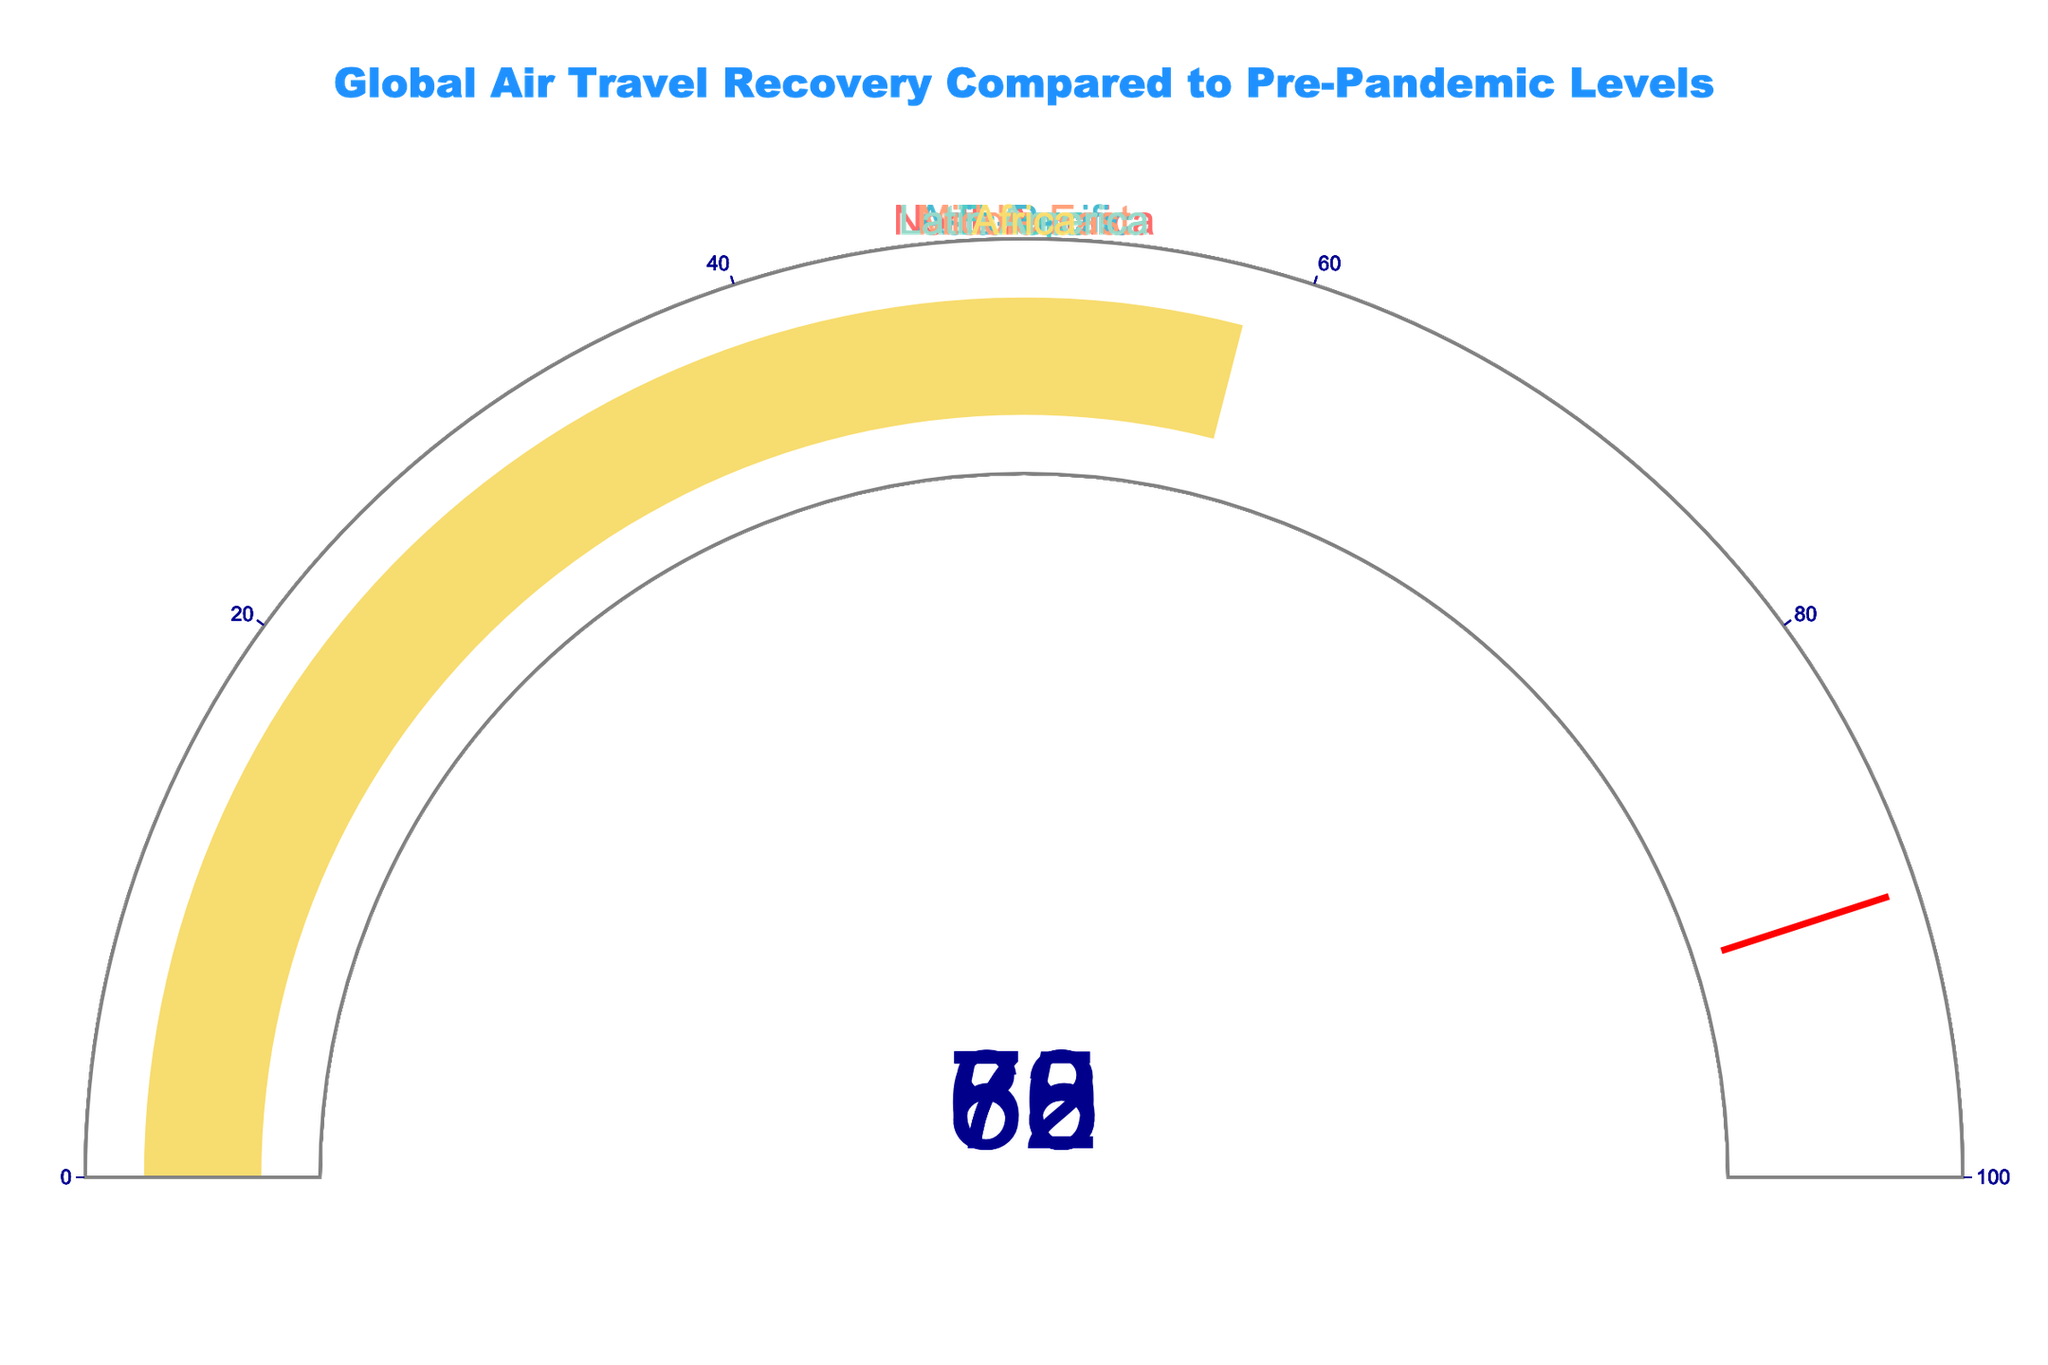What's the region with the highest air travel recovery percentage? The figure shows six regions with their respective recovery percentages. By inspecting the gauges, North America has the highest value at 85%.
Answer: North America What's the difference in air travel recovery between the highest and lowest regions? The highest recovery percentage is 85% (North America), and the lowest is 58% (Africa). The difference is calculated as 85% - 58%.
Answer: 27% Which two regions have recovery percentages above 75%? By looking at the gauges, North America (85%) and Europe (78%) have values above 75%.
Answer: North America and Europe What's the average recovery percentage of all regions combined? The recovery percentages are 85, 78, 62, 70, 73, and 58. Sum them up: 85 + 78 + 62 + 70 + 73 + 58 = 426. Divide by the number of regions (6).
Answer: 71% Which region falls exactly in the middle in terms of recovery percentage? When ordered, the percentages are 58, 62, 70, 73, 78, and 85. The middle two values are 70 and 73. Therefore, Middle East with 70% falls in the middle.
Answer: Middle East Which regions have recovery percentages below 65%? Inspecting the gauges, Asia-Pacific (62%) and Africa (58%) have recovery percentages below 65%.
Answer: Asia-Pacific and Africa How much more recovery does Asia-Pacific need to reach North America's level? North America's recovery is 85%, and Asia-Pacific's is 62%. Calculate the difference: 85% - 62%.
Answer: 23% What's the range of recovery percentages shown in the figure? The highest percentage is 85% (North America), and the lowest is 58% (Africa). The range is calculated by subtracting the lowest from the highest: 85% - 58%.
Answer: 27% Which region is closest to recovering to pre-pandemic levels? The closest region to full recovery is the one with the highest percentage, which is North America at 85%.
Answer: North America What is the sum of the recovery percentages of Europe, Middle East, and Latin America? The recovery percentages are 78 (Europe), 70 (Middle East), and 73 (Latin America). Sum them up: 78 + 70 + 73.
Answer: 221 